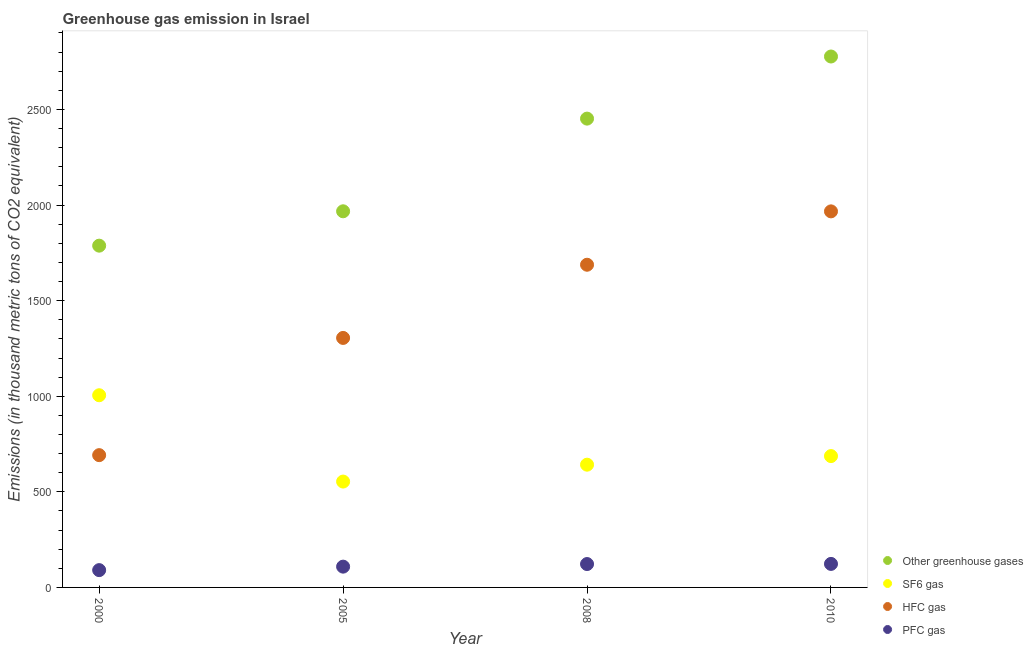How many different coloured dotlines are there?
Offer a terse response. 4. Is the number of dotlines equal to the number of legend labels?
Give a very brief answer. Yes. What is the emission of hfc gas in 2008?
Make the answer very short. 1687.8. Across all years, what is the maximum emission of hfc gas?
Offer a terse response. 1967. Across all years, what is the minimum emission of sf6 gas?
Keep it short and to the point. 553.7. In which year was the emission of hfc gas maximum?
Offer a very short reply. 2010. What is the total emission of pfc gas in the graph?
Provide a short and direct response. 444.5. What is the difference between the emission of pfc gas in 2000 and that in 2010?
Keep it short and to the point. -32.5. What is the difference between the emission of hfc gas in 2005 and the emission of sf6 gas in 2008?
Offer a very short reply. 663. What is the average emission of sf6 gas per year?
Keep it short and to the point. 721.98. In the year 2000, what is the difference between the emission of sf6 gas and emission of hfc gas?
Your answer should be very brief. 313.3. What is the ratio of the emission of greenhouse gases in 2008 to that in 2010?
Provide a short and direct response. 0.88. Is the emission of hfc gas in 2000 less than that in 2008?
Provide a short and direct response. Yes. Is the difference between the emission of pfc gas in 2000 and 2008 greater than the difference between the emission of greenhouse gases in 2000 and 2008?
Provide a short and direct response. Yes. What is the difference between the highest and the second highest emission of greenhouse gases?
Your answer should be compact. 324.9. What is the difference between the highest and the lowest emission of greenhouse gases?
Make the answer very short. 989.4. Is it the case that in every year, the sum of the emission of sf6 gas and emission of greenhouse gases is greater than the sum of emission of hfc gas and emission of pfc gas?
Your answer should be compact. No. Does the emission of sf6 gas monotonically increase over the years?
Give a very brief answer. No. Is the emission of sf6 gas strictly greater than the emission of greenhouse gases over the years?
Give a very brief answer. No. How many dotlines are there?
Offer a very short reply. 4. Does the graph contain any zero values?
Your answer should be very brief. No. Does the graph contain grids?
Provide a short and direct response. No. How many legend labels are there?
Give a very brief answer. 4. How are the legend labels stacked?
Offer a terse response. Vertical. What is the title of the graph?
Provide a succinct answer. Greenhouse gas emission in Israel. What is the label or title of the X-axis?
Ensure brevity in your answer.  Year. What is the label or title of the Y-axis?
Your answer should be very brief. Emissions (in thousand metric tons of CO2 equivalent). What is the Emissions (in thousand metric tons of CO2 equivalent) in Other greenhouse gases in 2000?
Your answer should be compact. 1787.6. What is the Emissions (in thousand metric tons of CO2 equivalent) in SF6 gas in 2000?
Your response must be concise. 1005.2. What is the Emissions (in thousand metric tons of CO2 equivalent) in HFC gas in 2000?
Provide a succinct answer. 691.9. What is the Emissions (in thousand metric tons of CO2 equivalent) of PFC gas in 2000?
Offer a very short reply. 90.5. What is the Emissions (in thousand metric tons of CO2 equivalent) in Other greenhouse gases in 2005?
Provide a succinct answer. 1967.4. What is the Emissions (in thousand metric tons of CO2 equivalent) of SF6 gas in 2005?
Provide a short and direct response. 553.7. What is the Emissions (in thousand metric tons of CO2 equivalent) in HFC gas in 2005?
Offer a very short reply. 1305. What is the Emissions (in thousand metric tons of CO2 equivalent) of PFC gas in 2005?
Give a very brief answer. 108.7. What is the Emissions (in thousand metric tons of CO2 equivalent) in Other greenhouse gases in 2008?
Provide a succinct answer. 2452.1. What is the Emissions (in thousand metric tons of CO2 equivalent) in SF6 gas in 2008?
Your answer should be compact. 642. What is the Emissions (in thousand metric tons of CO2 equivalent) in HFC gas in 2008?
Keep it short and to the point. 1687.8. What is the Emissions (in thousand metric tons of CO2 equivalent) in PFC gas in 2008?
Your response must be concise. 122.3. What is the Emissions (in thousand metric tons of CO2 equivalent) of Other greenhouse gases in 2010?
Offer a terse response. 2777. What is the Emissions (in thousand metric tons of CO2 equivalent) in SF6 gas in 2010?
Provide a succinct answer. 687. What is the Emissions (in thousand metric tons of CO2 equivalent) in HFC gas in 2010?
Keep it short and to the point. 1967. What is the Emissions (in thousand metric tons of CO2 equivalent) of PFC gas in 2010?
Provide a short and direct response. 123. Across all years, what is the maximum Emissions (in thousand metric tons of CO2 equivalent) in Other greenhouse gases?
Offer a terse response. 2777. Across all years, what is the maximum Emissions (in thousand metric tons of CO2 equivalent) in SF6 gas?
Offer a terse response. 1005.2. Across all years, what is the maximum Emissions (in thousand metric tons of CO2 equivalent) in HFC gas?
Offer a terse response. 1967. Across all years, what is the maximum Emissions (in thousand metric tons of CO2 equivalent) of PFC gas?
Provide a short and direct response. 123. Across all years, what is the minimum Emissions (in thousand metric tons of CO2 equivalent) in Other greenhouse gases?
Ensure brevity in your answer.  1787.6. Across all years, what is the minimum Emissions (in thousand metric tons of CO2 equivalent) of SF6 gas?
Your answer should be compact. 553.7. Across all years, what is the minimum Emissions (in thousand metric tons of CO2 equivalent) in HFC gas?
Keep it short and to the point. 691.9. Across all years, what is the minimum Emissions (in thousand metric tons of CO2 equivalent) of PFC gas?
Your answer should be compact. 90.5. What is the total Emissions (in thousand metric tons of CO2 equivalent) of Other greenhouse gases in the graph?
Your response must be concise. 8984.1. What is the total Emissions (in thousand metric tons of CO2 equivalent) of SF6 gas in the graph?
Give a very brief answer. 2887.9. What is the total Emissions (in thousand metric tons of CO2 equivalent) of HFC gas in the graph?
Ensure brevity in your answer.  5651.7. What is the total Emissions (in thousand metric tons of CO2 equivalent) in PFC gas in the graph?
Offer a terse response. 444.5. What is the difference between the Emissions (in thousand metric tons of CO2 equivalent) of Other greenhouse gases in 2000 and that in 2005?
Offer a terse response. -179.8. What is the difference between the Emissions (in thousand metric tons of CO2 equivalent) of SF6 gas in 2000 and that in 2005?
Offer a very short reply. 451.5. What is the difference between the Emissions (in thousand metric tons of CO2 equivalent) of HFC gas in 2000 and that in 2005?
Your answer should be compact. -613.1. What is the difference between the Emissions (in thousand metric tons of CO2 equivalent) in PFC gas in 2000 and that in 2005?
Offer a terse response. -18.2. What is the difference between the Emissions (in thousand metric tons of CO2 equivalent) of Other greenhouse gases in 2000 and that in 2008?
Provide a succinct answer. -664.5. What is the difference between the Emissions (in thousand metric tons of CO2 equivalent) in SF6 gas in 2000 and that in 2008?
Provide a short and direct response. 363.2. What is the difference between the Emissions (in thousand metric tons of CO2 equivalent) of HFC gas in 2000 and that in 2008?
Provide a succinct answer. -995.9. What is the difference between the Emissions (in thousand metric tons of CO2 equivalent) of PFC gas in 2000 and that in 2008?
Provide a succinct answer. -31.8. What is the difference between the Emissions (in thousand metric tons of CO2 equivalent) of Other greenhouse gases in 2000 and that in 2010?
Keep it short and to the point. -989.4. What is the difference between the Emissions (in thousand metric tons of CO2 equivalent) in SF6 gas in 2000 and that in 2010?
Your answer should be very brief. 318.2. What is the difference between the Emissions (in thousand metric tons of CO2 equivalent) in HFC gas in 2000 and that in 2010?
Provide a succinct answer. -1275.1. What is the difference between the Emissions (in thousand metric tons of CO2 equivalent) of PFC gas in 2000 and that in 2010?
Make the answer very short. -32.5. What is the difference between the Emissions (in thousand metric tons of CO2 equivalent) of Other greenhouse gases in 2005 and that in 2008?
Make the answer very short. -484.7. What is the difference between the Emissions (in thousand metric tons of CO2 equivalent) in SF6 gas in 2005 and that in 2008?
Provide a succinct answer. -88.3. What is the difference between the Emissions (in thousand metric tons of CO2 equivalent) of HFC gas in 2005 and that in 2008?
Make the answer very short. -382.8. What is the difference between the Emissions (in thousand metric tons of CO2 equivalent) in PFC gas in 2005 and that in 2008?
Your response must be concise. -13.6. What is the difference between the Emissions (in thousand metric tons of CO2 equivalent) of Other greenhouse gases in 2005 and that in 2010?
Your answer should be very brief. -809.6. What is the difference between the Emissions (in thousand metric tons of CO2 equivalent) of SF6 gas in 2005 and that in 2010?
Your answer should be compact. -133.3. What is the difference between the Emissions (in thousand metric tons of CO2 equivalent) of HFC gas in 2005 and that in 2010?
Give a very brief answer. -662. What is the difference between the Emissions (in thousand metric tons of CO2 equivalent) of PFC gas in 2005 and that in 2010?
Keep it short and to the point. -14.3. What is the difference between the Emissions (in thousand metric tons of CO2 equivalent) of Other greenhouse gases in 2008 and that in 2010?
Your answer should be very brief. -324.9. What is the difference between the Emissions (in thousand metric tons of CO2 equivalent) in SF6 gas in 2008 and that in 2010?
Offer a terse response. -45. What is the difference between the Emissions (in thousand metric tons of CO2 equivalent) in HFC gas in 2008 and that in 2010?
Provide a succinct answer. -279.2. What is the difference between the Emissions (in thousand metric tons of CO2 equivalent) of PFC gas in 2008 and that in 2010?
Offer a terse response. -0.7. What is the difference between the Emissions (in thousand metric tons of CO2 equivalent) in Other greenhouse gases in 2000 and the Emissions (in thousand metric tons of CO2 equivalent) in SF6 gas in 2005?
Offer a very short reply. 1233.9. What is the difference between the Emissions (in thousand metric tons of CO2 equivalent) in Other greenhouse gases in 2000 and the Emissions (in thousand metric tons of CO2 equivalent) in HFC gas in 2005?
Your answer should be compact. 482.6. What is the difference between the Emissions (in thousand metric tons of CO2 equivalent) in Other greenhouse gases in 2000 and the Emissions (in thousand metric tons of CO2 equivalent) in PFC gas in 2005?
Your answer should be very brief. 1678.9. What is the difference between the Emissions (in thousand metric tons of CO2 equivalent) of SF6 gas in 2000 and the Emissions (in thousand metric tons of CO2 equivalent) of HFC gas in 2005?
Provide a succinct answer. -299.8. What is the difference between the Emissions (in thousand metric tons of CO2 equivalent) in SF6 gas in 2000 and the Emissions (in thousand metric tons of CO2 equivalent) in PFC gas in 2005?
Your response must be concise. 896.5. What is the difference between the Emissions (in thousand metric tons of CO2 equivalent) of HFC gas in 2000 and the Emissions (in thousand metric tons of CO2 equivalent) of PFC gas in 2005?
Make the answer very short. 583.2. What is the difference between the Emissions (in thousand metric tons of CO2 equivalent) of Other greenhouse gases in 2000 and the Emissions (in thousand metric tons of CO2 equivalent) of SF6 gas in 2008?
Make the answer very short. 1145.6. What is the difference between the Emissions (in thousand metric tons of CO2 equivalent) of Other greenhouse gases in 2000 and the Emissions (in thousand metric tons of CO2 equivalent) of HFC gas in 2008?
Provide a short and direct response. 99.8. What is the difference between the Emissions (in thousand metric tons of CO2 equivalent) in Other greenhouse gases in 2000 and the Emissions (in thousand metric tons of CO2 equivalent) in PFC gas in 2008?
Your answer should be very brief. 1665.3. What is the difference between the Emissions (in thousand metric tons of CO2 equivalent) in SF6 gas in 2000 and the Emissions (in thousand metric tons of CO2 equivalent) in HFC gas in 2008?
Provide a short and direct response. -682.6. What is the difference between the Emissions (in thousand metric tons of CO2 equivalent) in SF6 gas in 2000 and the Emissions (in thousand metric tons of CO2 equivalent) in PFC gas in 2008?
Make the answer very short. 882.9. What is the difference between the Emissions (in thousand metric tons of CO2 equivalent) in HFC gas in 2000 and the Emissions (in thousand metric tons of CO2 equivalent) in PFC gas in 2008?
Offer a very short reply. 569.6. What is the difference between the Emissions (in thousand metric tons of CO2 equivalent) of Other greenhouse gases in 2000 and the Emissions (in thousand metric tons of CO2 equivalent) of SF6 gas in 2010?
Your answer should be compact. 1100.6. What is the difference between the Emissions (in thousand metric tons of CO2 equivalent) of Other greenhouse gases in 2000 and the Emissions (in thousand metric tons of CO2 equivalent) of HFC gas in 2010?
Keep it short and to the point. -179.4. What is the difference between the Emissions (in thousand metric tons of CO2 equivalent) in Other greenhouse gases in 2000 and the Emissions (in thousand metric tons of CO2 equivalent) in PFC gas in 2010?
Provide a short and direct response. 1664.6. What is the difference between the Emissions (in thousand metric tons of CO2 equivalent) of SF6 gas in 2000 and the Emissions (in thousand metric tons of CO2 equivalent) of HFC gas in 2010?
Make the answer very short. -961.8. What is the difference between the Emissions (in thousand metric tons of CO2 equivalent) of SF6 gas in 2000 and the Emissions (in thousand metric tons of CO2 equivalent) of PFC gas in 2010?
Give a very brief answer. 882.2. What is the difference between the Emissions (in thousand metric tons of CO2 equivalent) of HFC gas in 2000 and the Emissions (in thousand metric tons of CO2 equivalent) of PFC gas in 2010?
Your answer should be very brief. 568.9. What is the difference between the Emissions (in thousand metric tons of CO2 equivalent) in Other greenhouse gases in 2005 and the Emissions (in thousand metric tons of CO2 equivalent) in SF6 gas in 2008?
Offer a terse response. 1325.4. What is the difference between the Emissions (in thousand metric tons of CO2 equivalent) in Other greenhouse gases in 2005 and the Emissions (in thousand metric tons of CO2 equivalent) in HFC gas in 2008?
Offer a terse response. 279.6. What is the difference between the Emissions (in thousand metric tons of CO2 equivalent) in Other greenhouse gases in 2005 and the Emissions (in thousand metric tons of CO2 equivalent) in PFC gas in 2008?
Give a very brief answer. 1845.1. What is the difference between the Emissions (in thousand metric tons of CO2 equivalent) of SF6 gas in 2005 and the Emissions (in thousand metric tons of CO2 equivalent) of HFC gas in 2008?
Your answer should be very brief. -1134.1. What is the difference between the Emissions (in thousand metric tons of CO2 equivalent) of SF6 gas in 2005 and the Emissions (in thousand metric tons of CO2 equivalent) of PFC gas in 2008?
Offer a very short reply. 431.4. What is the difference between the Emissions (in thousand metric tons of CO2 equivalent) in HFC gas in 2005 and the Emissions (in thousand metric tons of CO2 equivalent) in PFC gas in 2008?
Give a very brief answer. 1182.7. What is the difference between the Emissions (in thousand metric tons of CO2 equivalent) in Other greenhouse gases in 2005 and the Emissions (in thousand metric tons of CO2 equivalent) in SF6 gas in 2010?
Your answer should be very brief. 1280.4. What is the difference between the Emissions (in thousand metric tons of CO2 equivalent) in Other greenhouse gases in 2005 and the Emissions (in thousand metric tons of CO2 equivalent) in PFC gas in 2010?
Keep it short and to the point. 1844.4. What is the difference between the Emissions (in thousand metric tons of CO2 equivalent) in SF6 gas in 2005 and the Emissions (in thousand metric tons of CO2 equivalent) in HFC gas in 2010?
Your answer should be compact. -1413.3. What is the difference between the Emissions (in thousand metric tons of CO2 equivalent) of SF6 gas in 2005 and the Emissions (in thousand metric tons of CO2 equivalent) of PFC gas in 2010?
Give a very brief answer. 430.7. What is the difference between the Emissions (in thousand metric tons of CO2 equivalent) of HFC gas in 2005 and the Emissions (in thousand metric tons of CO2 equivalent) of PFC gas in 2010?
Make the answer very short. 1182. What is the difference between the Emissions (in thousand metric tons of CO2 equivalent) in Other greenhouse gases in 2008 and the Emissions (in thousand metric tons of CO2 equivalent) in SF6 gas in 2010?
Keep it short and to the point. 1765.1. What is the difference between the Emissions (in thousand metric tons of CO2 equivalent) of Other greenhouse gases in 2008 and the Emissions (in thousand metric tons of CO2 equivalent) of HFC gas in 2010?
Give a very brief answer. 485.1. What is the difference between the Emissions (in thousand metric tons of CO2 equivalent) of Other greenhouse gases in 2008 and the Emissions (in thousand metric tons of CO2 equivalent) of PFC gas in 2010?
Your answer should be compact. 2329.1. What is the difference between the Emissions (in thousand metric tons of CO2 equivalent) in SF6 gas in 2008 and the Emissions (in thousand metric tons of CO2 equivalent) in HFC gas in 2010?
Your response must be concise. -1325. What is the difference between the Emissions (in thousand metric tons of CO2 equivalent) of SF6 gas in 2008 and the Emissions (in thousand metric tons of CO2 equivalent) of PFC gas in 2010?
Offer a terse response. 519. What is the difference between the Emissions (in thousand metric tons of CO2 equivalent) of HFC gas in 2008 and the Emissions (in thousand metric tons of CO2 equivalent) of PFC gas in 2010?
Provide a short and direct response. 1564.8. What is the average Emissions (in thousand metric tons of CO2 equivalent) in Other greenhouse gases per year?
Provide a succinct answer. 2246.03. What is the average Emissions (in thousand metric tons of CO2 equivalent) of SF6 gas per year?
Provide a short and direct response. 721.98. What is the average Emissions (in thousand metric tons of CO2 equivalent) in HFC gas per year?
Ensure brevity in your answer.  1412.92. What is the average Emissions (in thousand metric tons of CO2 equivalent) in PFC gas per year?
Keep it short and to the point. 111.12. In the year 2000, what is the difference between the Emissions (in thousand metric tons of CO2 equivalent) in Other greenhouse gases and Emissions (in thousand metric tons of CO2 equivalent) in SF6 gas?
Your answer should be very brief. 782.4. In the year 2000, what is the difference between the Emissions (in thousand metric tons of CO2 equivalent) of Other greenhouse gases and Emissions (in thousand metric tons of CO2 equivalent) of HFC gas?
Offer a very short reply. 1095.7. In the year 2000, what is the difference between the Emissions (in thousand metric tons of CO2 equivalent) in Other greenhouse gases and Emissions (in thousand metric tons of CO2 equivalent) in PFC gas?
Ensure brevity in your answer.  1697.1. In the year 2000, what is the difference between the Emissions (in thousand metric tons of CO2 equivalent) of SF6 gas and Emissions (in thousand metric tons of CO2 equivalent) of HFC gas?
Provide a short and direct response. 313.3. In the year 2000, what is the difference between the Emissions (in thousand metric tons of CO2 equivalent) in SF6 gas and Emissions (in thousand metric tons of CO2 equivalent) in PFC gas?
Ensure brevity in your answer.  914.7. In the year 2000, what is the difference between the Emissions (in thousand metric tons of CO2 equivalent) of HFC gas and Emissions (in thousand metric tons of CO2 equivalent) of PFC gas?
Your answer should be compact. 601.4. In the year 2005, what is the difference between the Emissions (in thousand metric tons of CO2 equivalent) of Other greenhouse gases and Emissions (in thousand metric tons of CO2 equivalent) of SF6 gas?
Offer a very short reply. 1413.7. In the year 2005, what is the difference between the Emissions (in thousand metric tons of CO2 equivalent) in Other greenhouse gases and Emissions (in thousand metric tons of CO2 equivalent) in HFC gas?
Ensure brevity in your answer.  662.4. In the year 2005, what is the difference between the Emissions (in thousand metric tons of CO2 equivalent) in Other greenhouse gases and Emissions (in thousand metric tons of CO2 equivalent) in PFC gas?
Your answer should be compact. 1858.7. In the year 2005, what is the difference between the Emissions (in thousand metric tons of CO2 equivalent) of SF6 gas and Emissions (in thousand metric tons of CO2 equivalent) of HFC gas?
Make the answer very short. -751.3. In the year 2005, what is the difference between the Emissions (in thousand metric tons of CO2 equivalent) in SF6 gas and Emissions (in thousand metric tons of CO2 equivalent) in PFC gas?
Your response must be concise. 445. In the year 2005, what is the difference between the Emissions (in thousand metric tons of CO2 equivalent) of HFC gas and Emissions (in thousand metric tons of CO2 equivalent) of PFC gas?
Your answer should be compact. 1196.3. In the year 2008, what is the difference between the Emissions (in thousand metric tons of CO2 equivalent) in Other greenhouse gases and Emissions (in thousand metric tons of CO2 equivalent) in SF6 gas?
Your answer should be very brief. 1810.1. In the year 2008, what is the difference between the Emissions (in thousand metric tons of CO2 equivalent) in Other greenhouse gases and Emissions (in thousand metric tons of CO2 equivalent) in HFC gas?
Ensure brevity in your answer.  764.3. In the year 2008, what is the difference between the Emissions (in thousand metric tons of CO2 equivalent) of Other greenhouse gases and Emissions (in thousand metric tons of CO2 equivalent) of PFC gas?
Offer a very short reply. 2329.8. In the year 2008, what is the difference between the Emissions (in thousand metric tons of CO2 equivalent) of SF6 gas and Emissions (in thousand metric tons of CO2 equivalent) of HFC gas?
Keep it short and to the point. -1045.8. In the year 2008, what is the difference between the Emissions (in thousand metric tons of CO2 equivalent) in SF6 gas and Emissions (in thousand metric tons of CO2 equivalent) in PFC gas?
Offer a very short reply. 519.7. In the year 2008, what is the difference between the Emissions (in thousand metric tons of CO2 equivalent) of HFC gas and Emissions (in thousand metric tons of CO2 equivalent) of PFC gas?
Your answer should be very brief. 1565.5. In the year 2010, what is the difference between the Emissions (in thousand metric tons of CO2 equivalent) of Other greenhouse gases and Emissions (in thousand metric tons of CO2 equivalent) of SF6 gas?
Offer a very short reply. 2090. In the year 2010, what is the difference between the Emissions (in thousand metric tons of CO2 equivalent) in Other greenhouse gases and Emissions (in thousand metric tons of CO2 equivalent) in HFC gas?
Offer a very short reply. 810. In the year 2010, what is the difference between the Emissions (in thousand metric tons of CO2 equivalent) in Other greenhouse gases and Emissions (in thousand metric tons of CO2 equivalent) in PFC gas?
Offer a terse response. 2654. In the year 2010, what is the difference between the Emissions (in thousand metric tons of CO2 equivalent) of SF6 gas and Emissions (in thousand metric tons of CO2 equivalent) of HFC gas?
Offer a terse response. -1280. In the year 2010, what is the difference between the Emissions (in thousand metric tons of CO2 equivalent) of SF6 gas and Emissions (in thousand metric tons of CO2 equivalent) of PFC gas?
Your answer should be compact. 564. In the year 2010, what is the difference between the Emissions (in thousand metric tons of CO2 equivalent) of HFC gas and Emissions (in thousand metric tons of CO2 equivalent) of PFC gas?
Your answer should be compact. 1844. What is the ratio of the Emissions (in thousand metric tons of CO2 equivalent) of Other greenhouse gases in 2000 to that in 2005?
Offer a terse response. 0.91. What is the ratio of the Emissions (in thousand metric tons of CO2 equivalent) of SF6 gas in 2000 to that in 2005?
Your answer should be very brief. 1.82. What is the ratio of the Emissions (in thousand metric tons of CO2 equivalent) of HFC gas in 2000 to that in 2005?
Offer a very short reply. 0.53. What is the ratio of the Emissions (in thousand metric tons of CO2 equivalent) of PFC gas in 2000 to that in 2005?
Make the answer very short. 0.83. What is the ratio of the Emissions (in thousand metric tons of CO2 equivalent) in Other greenhouse gases in 2000 to that in 2008?
Keep it short and to the point. 0.73. What is the ratio of the Emissions (in thousand metric tons of CO2 equivalent) in SF6 gas in 2000 to that in 2008?
Provide a short and direct response. 1.57. What is the ratio of the Emissions (in thousand metric tons of CO2 equivalent) in HFC gas in 2000 to that in 2008?
Offer a very short reply. 0.41. What is the ratio of the Emissions (in thousand metric tons of CO2 equivalent) in PFC gas in 2000 to that in 2008?
Your answer should be very brief. 0.74. What is the ratio of the Emissions (in thousand metric tons of CO2 equivalent) of Other greenhouse gases in 2000 to that in 2010?
Provide a short and direct response. 0.64. What is the ratio of the Emissions (in thousand metric tons of CO2 equivalent) in SF6 gas in 2000 to that in 2010?
Give a very brief answer. 1.46. What is the ratio of the Emissions (in thousand metric tons of CO2 equivalent) of HFC gas in 2000 to that in 2010?
Provide a short and direct response. 0.35. What is the ratio of the Emissions (in thousand metric tons of CO2 equivalent) of PFC gas in 2000 to that in 2010?
Your response must be concise. 0.74. What is the ratio of the Emissions (in thousand metric tons of CO2 equivalent) in Other greenhouse gases in 2005 to that in 2008?
Your answer should be very brief. 0.8. What is the ratio of the Emissions (in thousand metric tons of CO2 equivalent) of SF6 gas in 2005 to that in 2008?
Make the answer very short. 0.86. What is the ratio of the Emissions (in thousand metric tons of CO2 equivalent) in HFC gas in 2005 to that in 2008?
Offer a very short reply. 0.77. What is the ratio of the Emissions (in thousand metric tons of CO2 equivalent) of PFC gas in 2005 to that in 2008?
Give a very brief answer. 0.89. What is the ratio of the Emissions (in thousand metric tons of CO2 equivalent) of Other greenhouse gases in 2005 to that in 2010?
Offer a very short reply. 0.71. What is the ratio of the Emissions (in thousand metric tons of CO2 equivalent) of SF6 gas in 2005 to that in 2010?
Provide a succinct answer. 0.81. What is the ratio of the Emissions (in thousand metric tons of CO2 equivalent) of HFC gas in 2005 to that in 2010?
Make the answer very short. 0.66. What is the ratio of the Emissions (in thousand metric tons of CO2 equivalent) of PFC gas in 2005 to that in 2010?
Your answer should be very brief. 0.88. What is the ratio of the Emissions (in thousand metric tons of CO2 equivalent) in Other greenhouse gases in 2008 to that in 2010?
Provide a succinct answer. 0.88. What is the ratio of the Emissions (in thousand metric tons of CO2 equivalent) in SF6 gas in 2008 to that in 2010?
Your answer should be very brief. 0.93. What is the ratio of the Emissions (in thousand metric tons of CO2 equivalent) of HFC gas in 2008 to that in 2010?
Provide a succinct answer. 0.86. What is the difference between the highest and the second highest Emissions (in thousand metric tons of CO2 equivalent) of Other greenhouse gases?
Give a very brief answer. 324.9. What is the difference between the highest and the second highest Emissions (in thousand metric tons of CO2 equivalent) of SF6 gas?
Your response must be concise. 318.2. What is the difference between the highest and the second highest Emissions (in thousand metric tons of CO2 equivalent) of HFC gas?
Your response must be concise. 279.2. What is the difference between the highest and the second highest Emissions (in thousand metric tons of CO2 equivalent) of PFC gas?
Offer a very short reply. 0.7. What is the difference between the highest and the lowest Emissions (in thousand metric tons of CO2 equivalent) in Other greenhouse gases?
Give a very brief answer. 989.4. What is the difference between the highest and the lowest Emissions (in thousand metric tons of CO2 equivalent) in SF6 gas?
Give a very brief answer. 451.5. What is the difference between the highest and the lowest Emissions (in thousand metric tons of CO2 equivalent) of HFC gas?
Offer a terse response. 1275.1. What is the difference between the highest and the lowest Emissions (in thousand metric tons of CO2 equivalent) of PFC gas?
Offer a terse response. 32.5. 